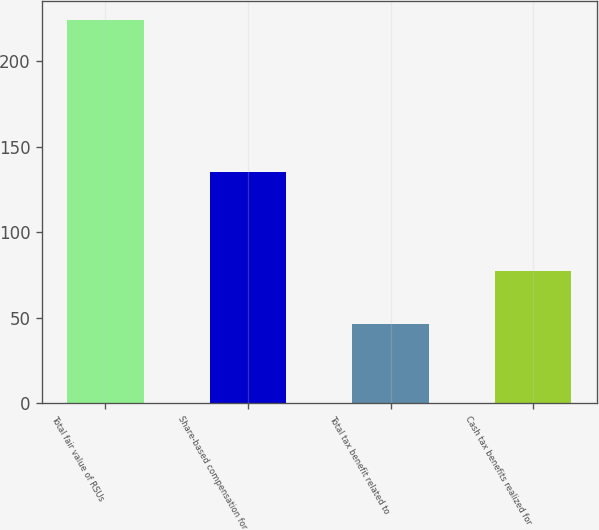<chart> <loc_0><loc_0><loc_500><loc_500><bar_chart><fcel>Total fair value of RSUs<fcel>Share-based compensation for<fcel>Total tax benefit related to<fcel>Cash tax benefits realized for<nl><fcel>224<fcel>135<fcel>46<fcel>77<nl></chart> 